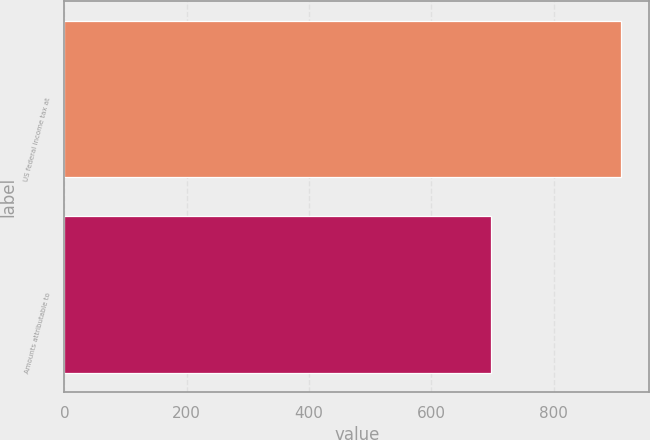Convert chart. <chart><loc_0><loc_0><loc_500><loc_500><bar_chart><fcel>US federal income tax at<fcel>Amounts attributable to<nl><fcel>911<fcel>698<nl></chart> 